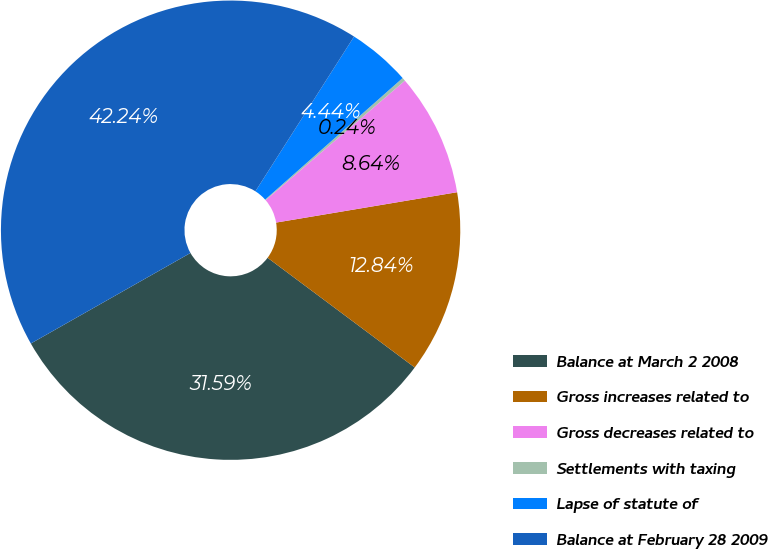<chart> <loc_0><loc_0><loc_500><loc_500><pie_chart><fcel>Balance at March 2 2008<fcel>Gross increases related to<fcel>Gross decreases related to<fcel>Settlements with taxing<fcel>Lapse of statute of<fcel>Balance at February 28 2009<nl><fcel>31.59%<fcel>12.84%<fcel>8.64%<fcel>0.24%<fcel>4.44%<fcel>42.24%<nl></chart> 